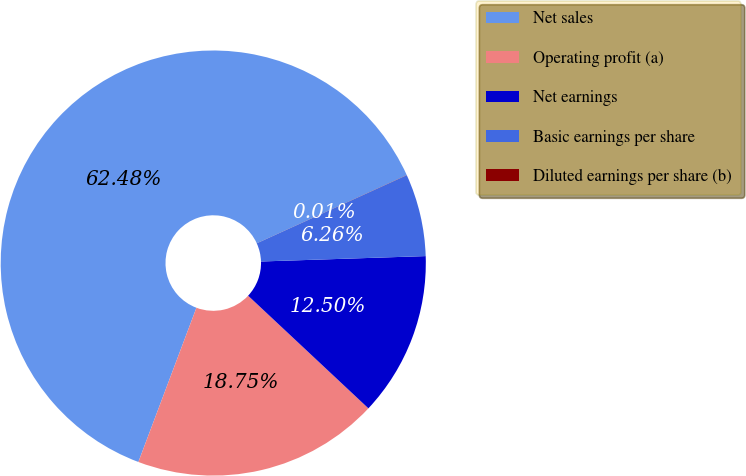Convert chart. <chart><loc_0><loc_0><loc_500><loc_500><pie_chart><fcel>Net sales<fcel>Operating profit (a)<fcel>Net earnings<fcel>Basic earnings per share<fcel>Diluted earnings per share (b)<nl><fcel>62.48%<fcel>18.75%<fcel>12.5%<fcel>6.26%<fcel>0.01%<nl></chart> 